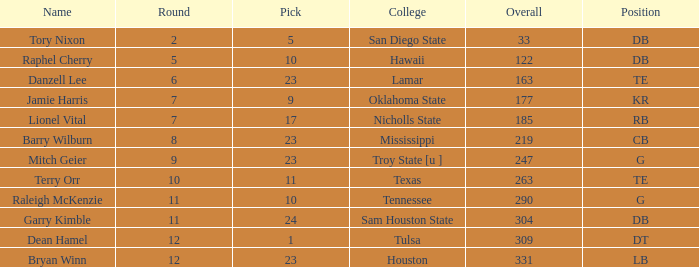How many Picks have an Overall smaller than 304, and a Position of g, and a Round smaller than 11? 1.0. 